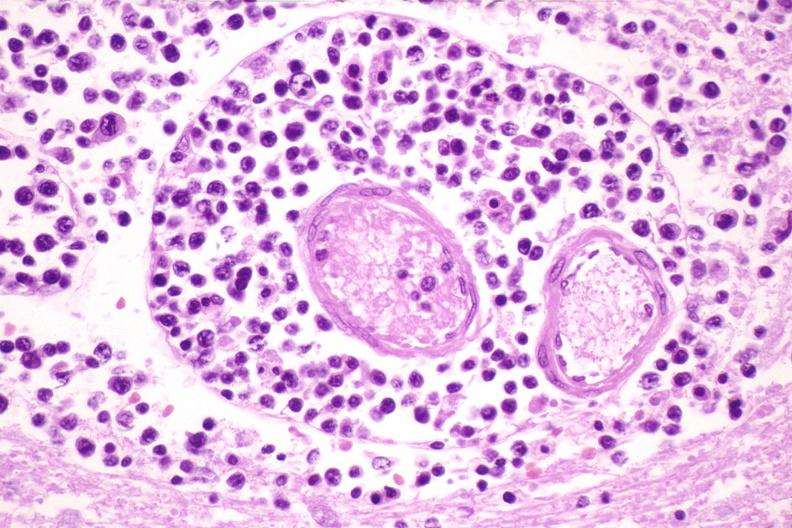s nervous present?
Answer the question using a single word or phrase. Yes 